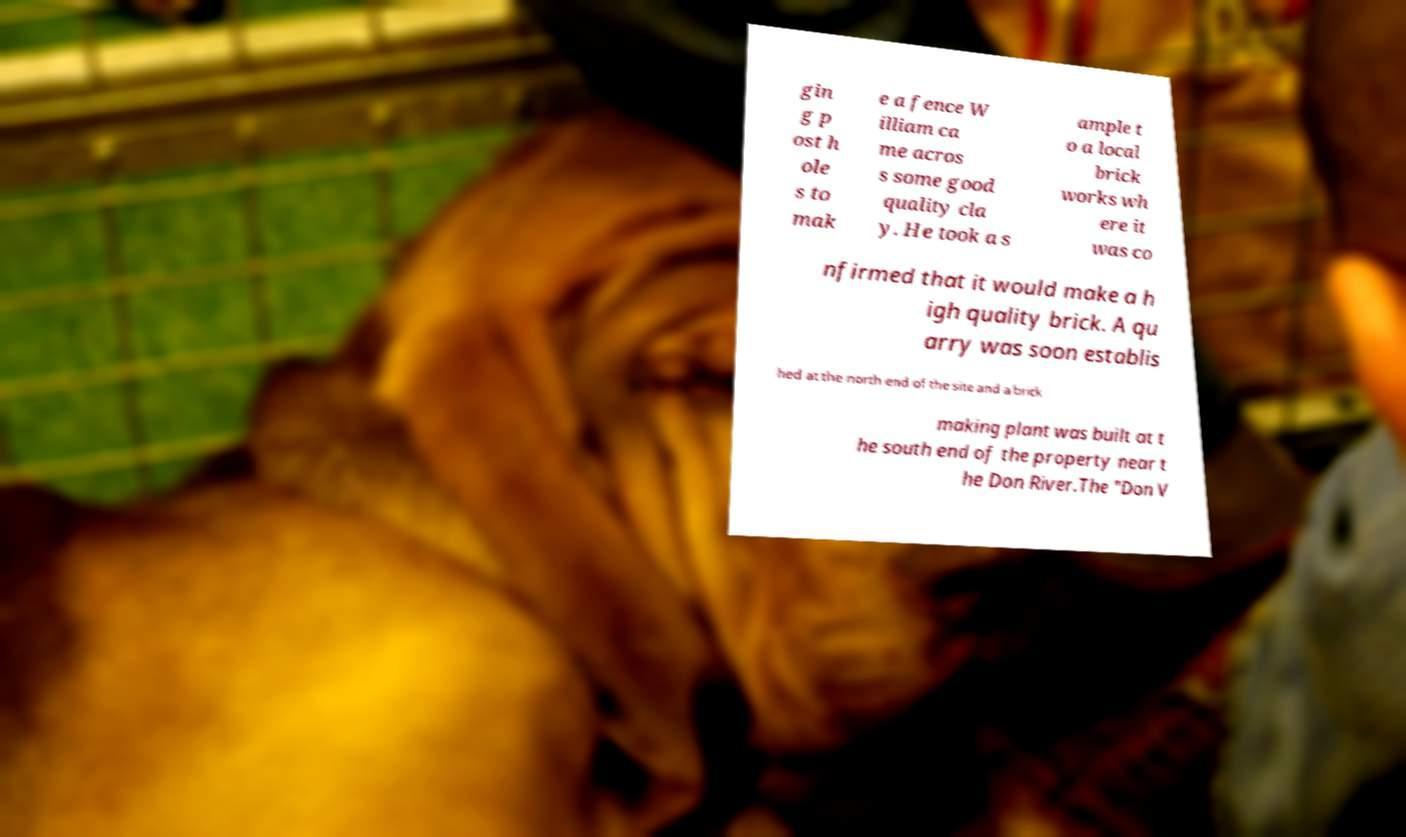Could you extract and type out the text from this image? gin g p ost h ole s to mak e a fence W illiam ca me acros s some good quality cla y. He took a s ample t o a local brick works wh ere it was co nfirmed that it would make a h igh quality brick. A qu arry was soon establis hed at the north end of the site and a brick making plant was built at t he south end of the property near t he Don River.The "Don V 